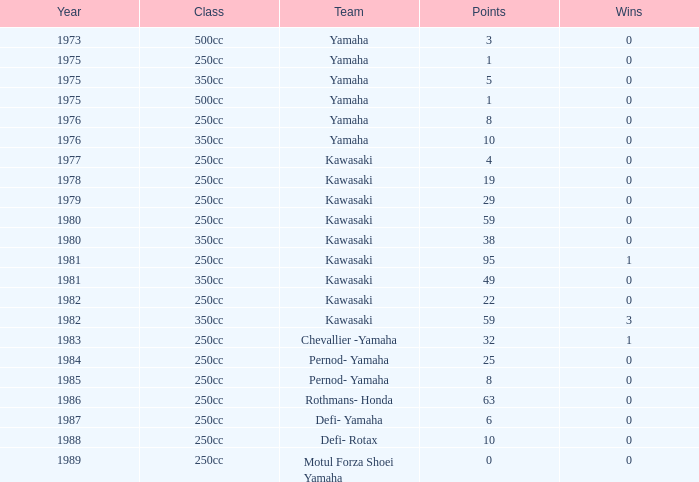What is the mean year number where there are more than 0 wins, the class is 250cc, and the points are 95? 1981.0. 